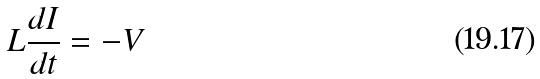<formula> <loc_0><loc_0><loc_500><loc_500>L \frac { d I } { d t } = - V</formula> 